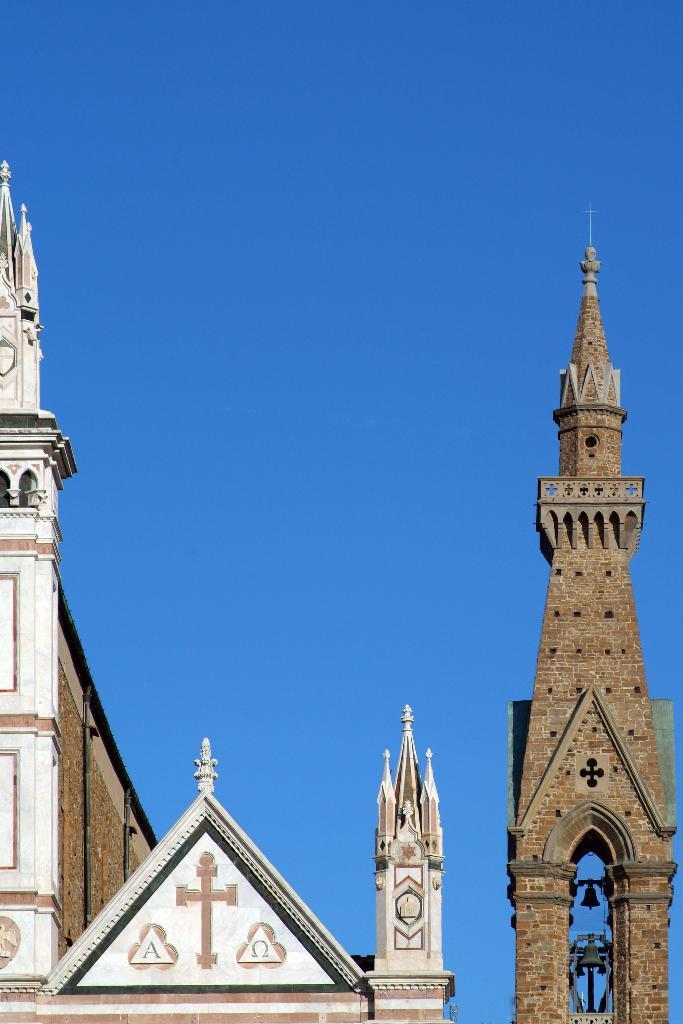What structures are present in the image? There are buildings or towers in the image. What part of the buildings or towers can be seen? The top portions of the buildings or towers are visible. What is visible at the top of the image? The sky is visible at the top of the image. How many teeth can be seen in the image? There are no teeth present in the image. What type of pump is visible in the image? There is no pump present in the image. 